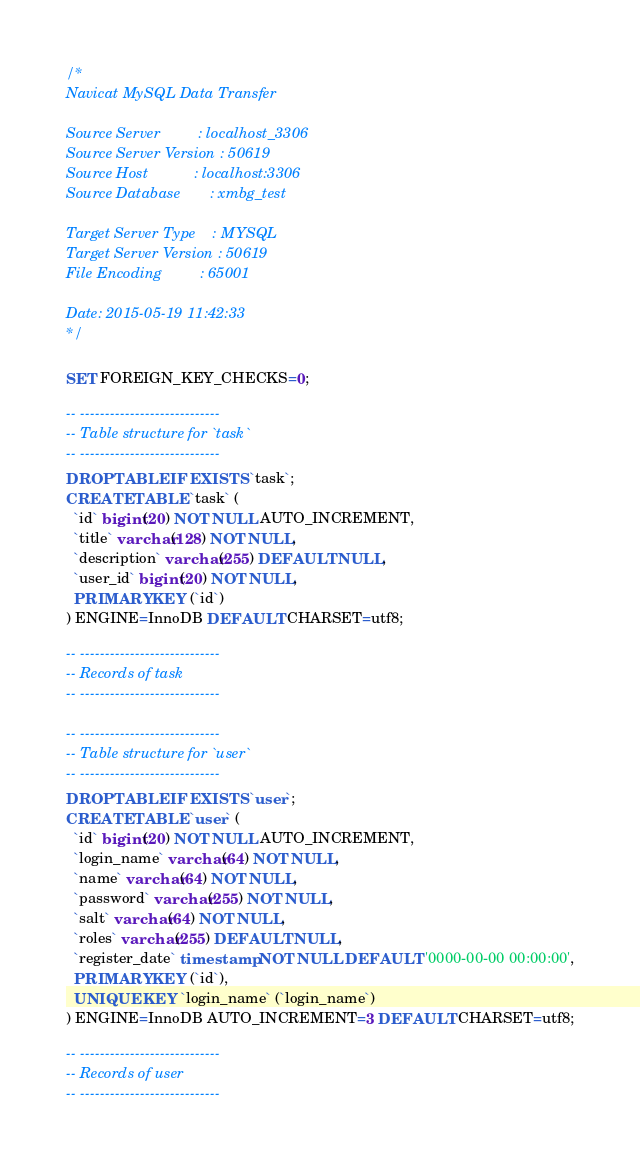<code> <loc_0><loc_0><loc_500><loc_500><_SQL_>/*
Navicat MySQL Data Transfer

Source Server         : localhost_3306
Source Server Version : 50619
Source Host           : localhost:3306
Source Database       : xmbg_test

Target Server Type    : MYSQL
Target Server Version : 50619
File Encoding         : 65001

Date: 2015-05-19 11:42:33
*/

SET FOREIGN_KEY_CHECKS=0;

-- ----------------------------
-- Table structure for `task`
-- ----------------------------
DROP TABLE IF EXISTS `task`;
CREATE TABLE `task` (
  `id` bigint(20) NOT NULL AUTO_INCREMENT,
  `title` varchar(128) NOT NULL,
  `description` varchar(255) DEFAULT NULL,
  `user_id` bigint(20) NOT NULL,
  PRIMARY KEY (`id`)
) ENGINE=InnoDB DEFAULT CHARSET=utf8;

-- ----------------------------
-- Records of task
-- ----------------------------

-- ----------------------------
-- Table structure for `user`
-- ----------------------------
DROP TABLE IF EXISTS `user`;
CREATE TABLE `user` (
  `id` bigint(20) NOT NULL AUTO_INCREMENT,
  `login_name` varchar(64) NOT NULL,
  `name` varchar(64) NOT NULL,
  `password` varchar(255) NOT NULL,
  `salt` varchar(64) NOT NULL,
  `roles` varchar(255) DEFAULT NULL,
  `register_date` timestamp NOT NULL DEFAULT '0000-00-00 00:00:00',
  PRIMARY KEY (`id`),
  UNIQUE KEY `login_name` (`login_name`)
) ENGINE=InnoDB AUTO_INCREMENT=3 DEFAULT CHARSET=utf8;

-- ----------------------------
-- Records of user
-- ----------------------------</code> 